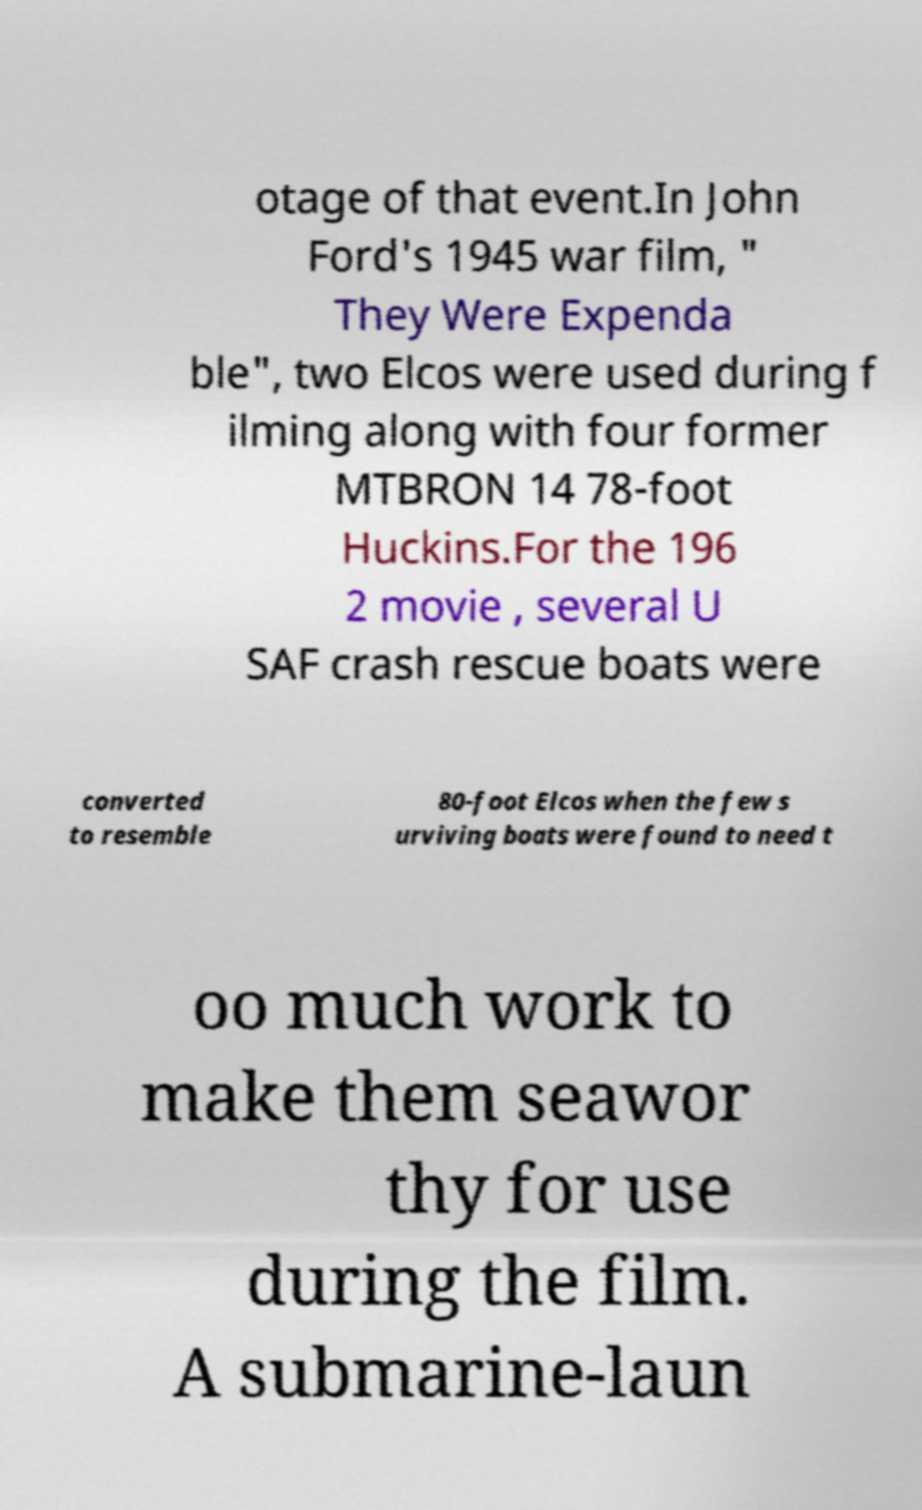What messages or text are displayed in this image? I need them in a readable, typed format. otage of that event.In John Ford's 1945 war film, " They Were Expenda ble", two Elcos were used during f ilming along with four former MTBRON 14 78-foot Huckins.For the 196 2 movie , several U SAF crash rescue boats were converted to resemble 80-foot Elcos when the few s urviving boats were found to need t oo much work to make them seawor thy for use during the film. A submarine-laun 